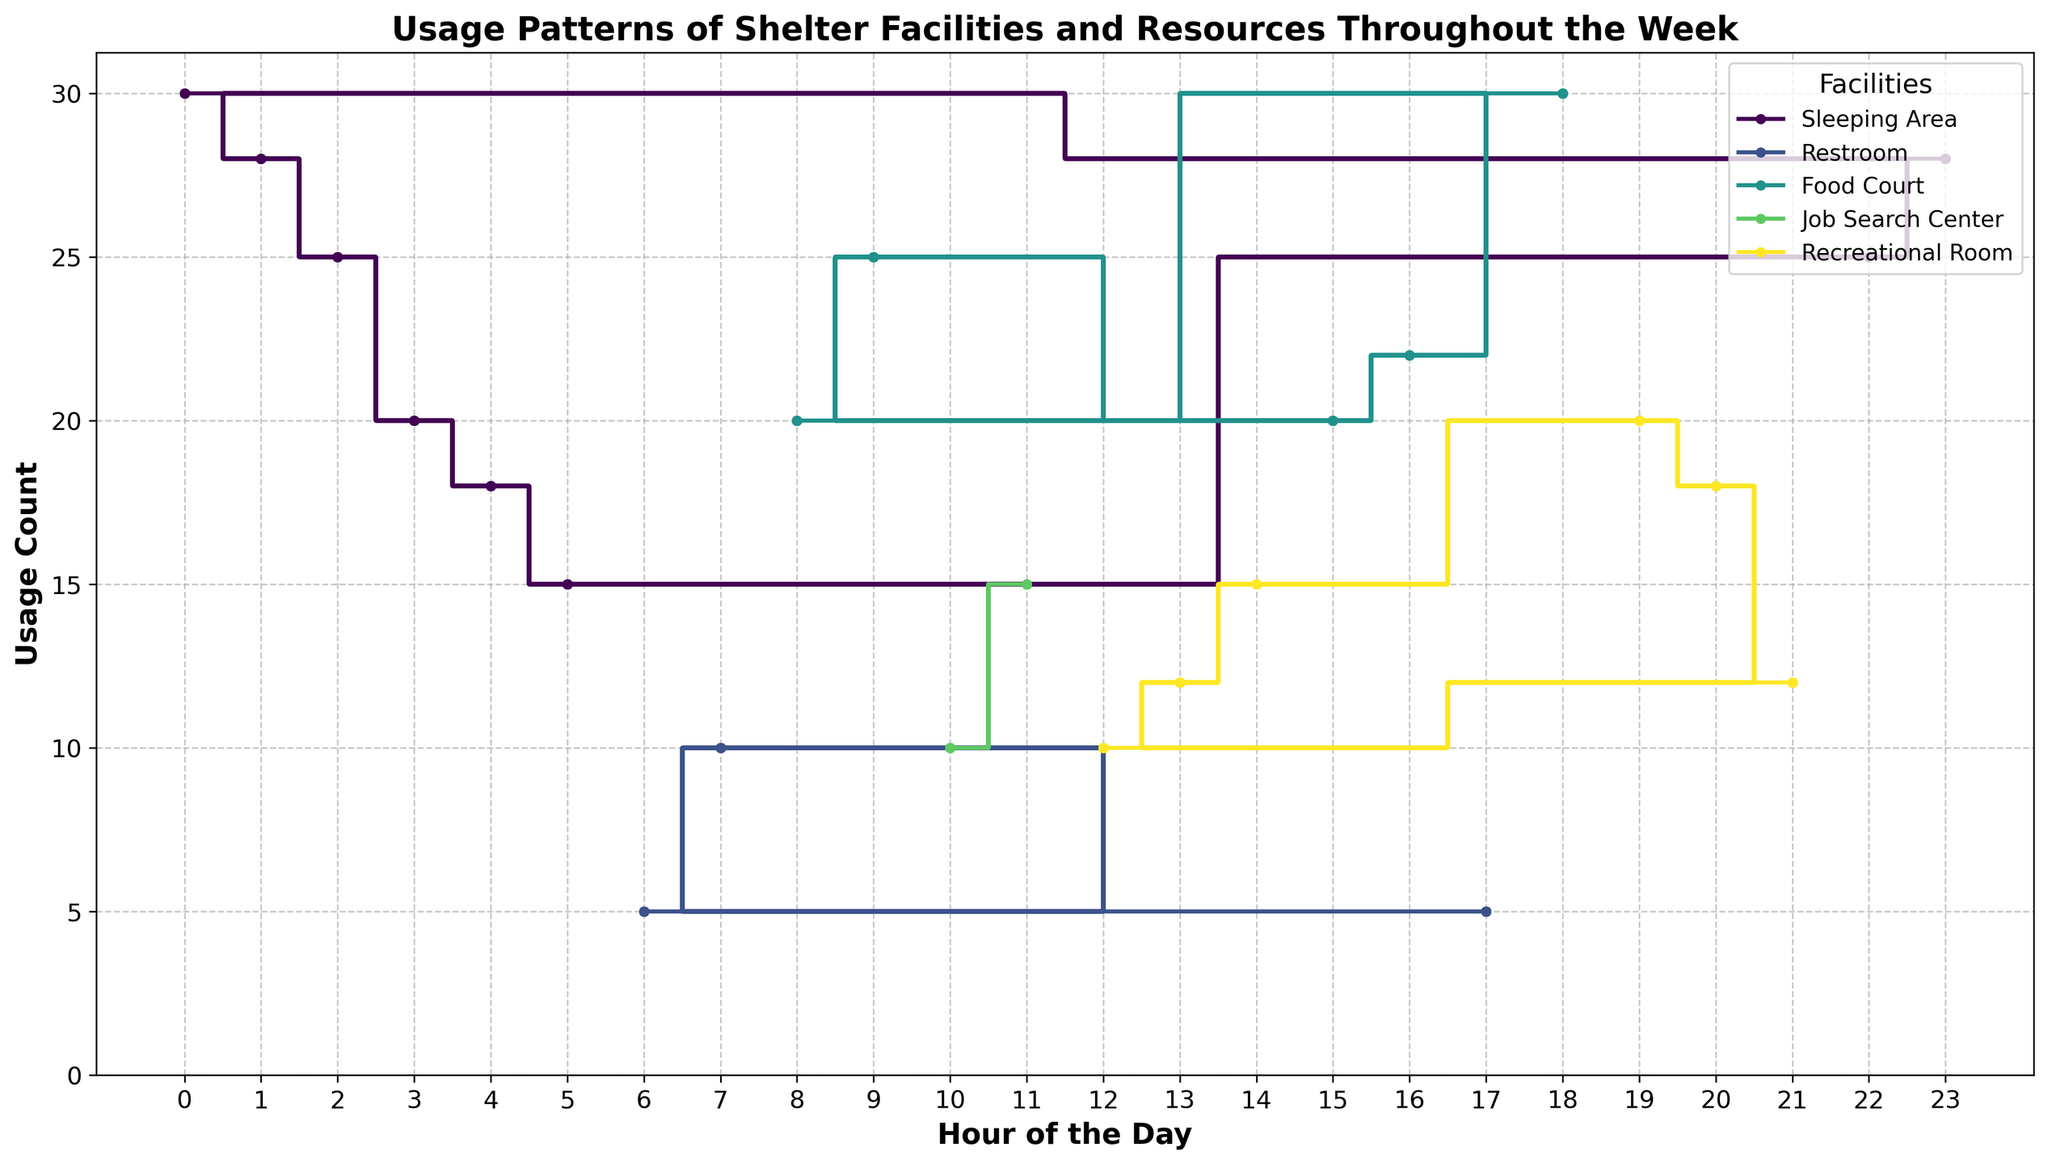What is the trend in the Food Court usage throughout the day? The figure will show the Food Court usage plotted against each hour. By tracing the line for the Food Court, we can identify how the usage changes over the 24-hour period, e.g., it might rise in the morning, drop in the afternoon, and peak in the evening.
Answer: Food Court usage peaks in the morning and evening Which facility has the highest usage at 18:00? Refer to the figure at the 18:00 time mark and compare the usage values represented by the different lines. Identify the facility with the highest data point at this time.
Answer: Food Court Is the Recreational Room usage higher in the morning or the evening? Look at the Recreational Room line for usage counts in the morning hours (e.g., 08:00-12:00) and evening hours (e.g., 17:00-21:00). Compare the counts to see which time has higher usage.
Answer: Evening At what hour does Restroom usage peak? Trace the Restroom line throughout the day to find the highest point. The hour corresponding to this peak is when the usage is highest.
Answer: 07:00 How does the pattern of Sleeping Area usage change overnight? Check the Sleeping Area line, focusing on the hours from the late evening (e.g., 22:00) through the early morning (e.g., 06:00). Observe how the usage changes in this period, noting any decreases or increases.
Answer: It decreases gradually towards the early morning What is the combined usage of the Recreational Room and Food Court at 14:00? Look at the usage counts for both the Recreational Room and Food Court at 14:00 in the figure. Add these values together to find the combined usage.
Answer: 35 Which facility has the most consistent usage throughout the day? Observe all the lines and identify the one with the least variation (most consistent usage) throughout the day.
Answer: Restroom Compare the morning usage (07:00-12:00) between the Job Search Center and the Restroom. Which has higher usage overall? Extract the data points for both facilities in the morning hours (07:00-12:00). Sum the usage counts for each facility, then compare to see which is higher.
Answer: Restroom What are the peak usage hours for the Shelter's Sleeping Area? Identify the highest points on the Sleeping Area line, noting the hours at which these peaks occur.
Answer: Midnight (00:00) Does the Food Court usage follow a consistent pattern each day? Compare the Food Court usage lines for different days of the week. Check if the peaks and troughs follow a similar pattern on each day.
Answer: Yes, it follows a consistent pattern 